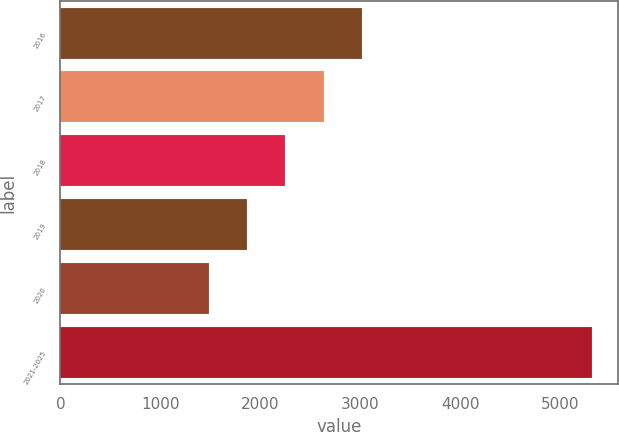Convert chart to OTSL. <chart><loc_0><loc_0><loc_500><loc_500><bar_chart><fcel>2016<fcel>2017<fcel>2018<fcel>2019<fcel>2020<fcel>2021-2025<nl><fcel>3015.6<fcel>2632.7<fcel>2249.8<fcel>1866.9<fcel>1484<fcel>5313<nl></chart> 